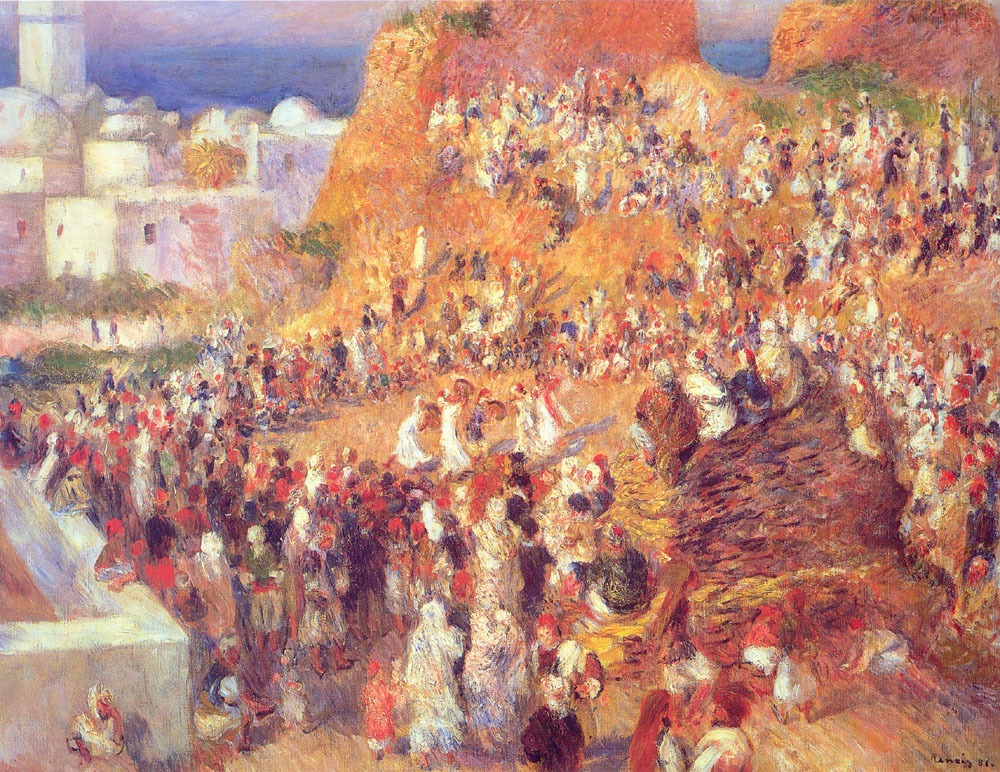Explain the visual content of the image in great detail. The image depicts an impressionist painting of a bustling market scene set in a Mediterranean town. The canvas is teeming with life, filled with people, buildings, and objects, all rendered in a vibrant palette. Warm hues of reds, oranges, and yellows dominate the scene, evoking the feeling of a sunny day. The art style is characterized by its loose and fluid brushwork, with visible strokes that give the painting its dynamic and lively feel. The figures and objects are not clearly defined, a hallmark of the impressionist genre, which focuses more on capturing the essence of the scene rather than the minute details. This painting is a beautiful representation of impressionism, capturing the energy and color of a Mediterranean market. 